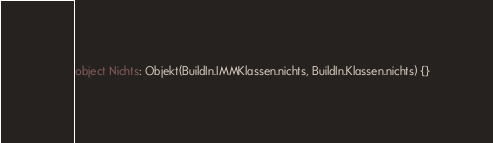Convert code to text. <code><loc_0><loc_0><loc_500><loc_500><_Kotlin_>
object Nichts: Objekt(BuildIn.IMMKlassen.nichts, BuildIn.Klassen.nichts) {}</code> 